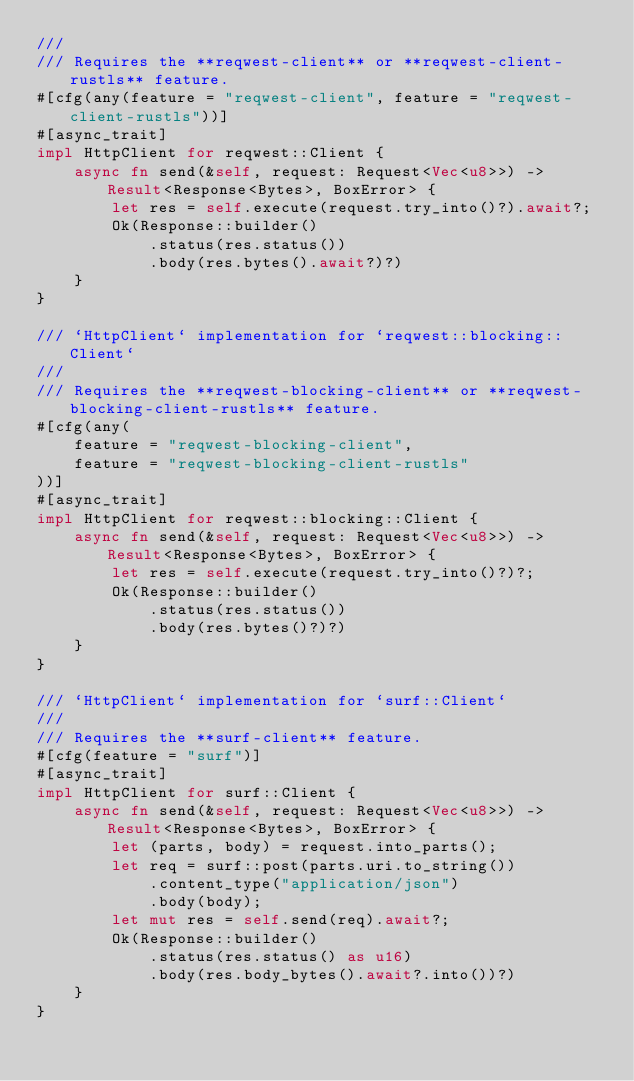Convert code to text. <code><loc_0><loc_0><loc_500><loc_500><_Rust_>///
/// Requires the **reqwest-client** or **reqwest-client-rustls** feature.
#[cfg(any(feature = "reqwest-client", feature = "reqwest-client-rustls"))]
#[async_trait]
impl HttpClient for reqwest::Client {
    async fn send(&self, request: Request<Vec<u8>>) -> Result<Response<Bytes>, BoxError> {
        let res = self.execute(request.try_into()?).await?;
        Ok(Response::builder()
            .status(res.status())
            .body(res.bytes().await?)?)
    }
}

/// `HttpClient` implementation for `reqwest::blocking::Client`
///
/// Requires the **reqwest-blocking-client** or **reqwest-blocking-client-rustls** feature.
#[cfg(any(
    feature = "reqwest-blocking-client",
    feature = "reqwest-blocking-client-rustls"
))]
#[async_trait]
impl HttpClient for reqwest::blocking::Client {
    async fn send(&self, request: Request<Vec<u8>>) -> Result<Response<Bytes>, BoxError> {
        let res = self.execute(request.try_into()?)?;
        Ok(Response::builder()
            .status(res.status())
            .body(res.bytes()?)?)
    }
}

/// `HttpClient` implementation for `surf::Client`
///
/// Requires the **surf-client** feature.
#[cfg(feature = "surf")]
#[async_trait]
impl HttpClient for surf::Client {
    async fn send(&self, request: Request<Vec<u8>>) -> Result<Response<Bytes>, BoxError> {
        let (parts, body) = request.into_parts();
        let req = surf::post(parts.uri.to_string())
            .content_type("application/json")
            .body(body);
        let mut res = self.send(req).await?;
        Ok(Response::builder()
            .status(res.status() as u16)
            .body(res.body_bytes().await?.into())?)
    }
}
</code> 